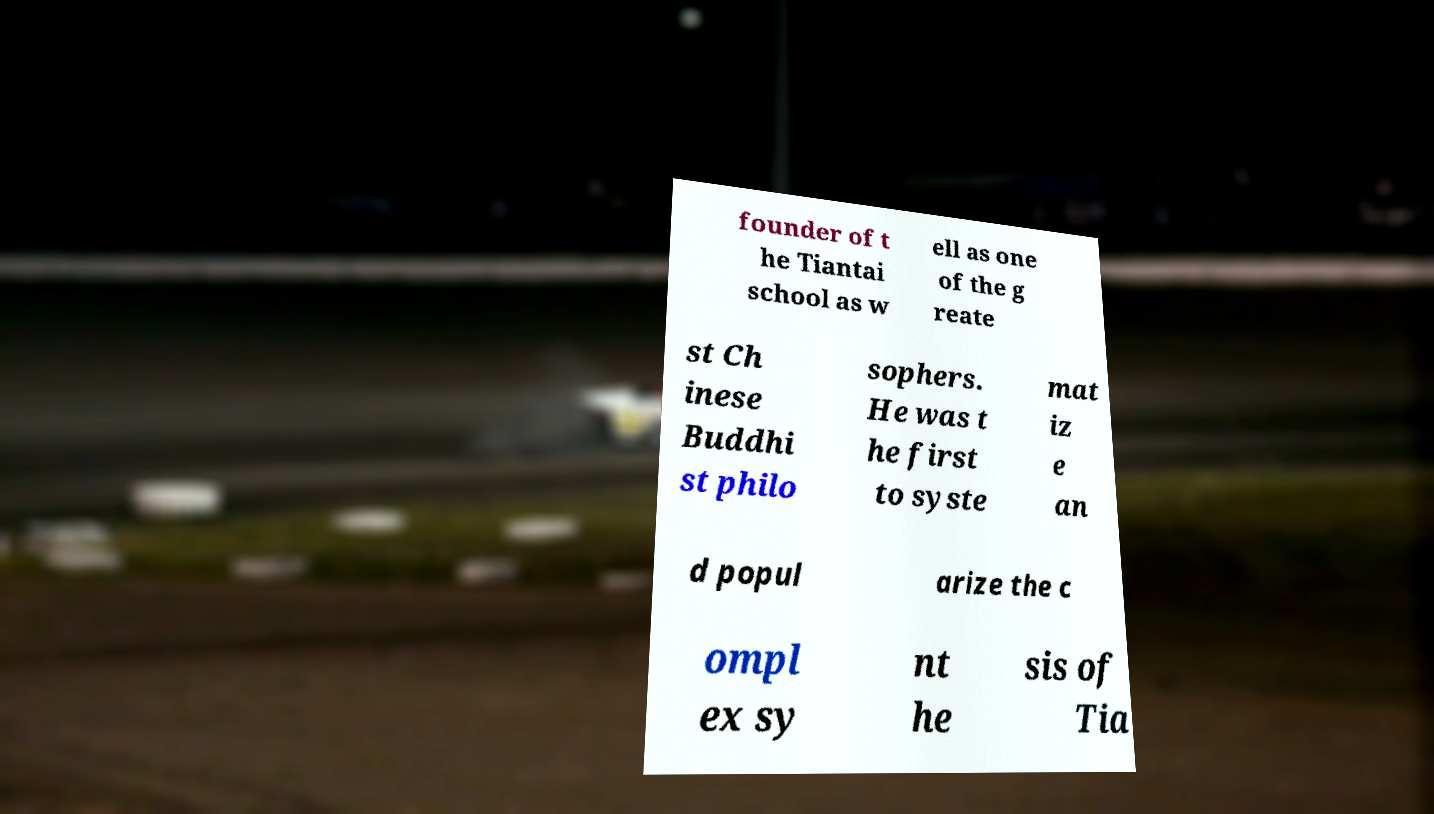Could you extract and type out the text from this image? founder of t he Tiantai school as w ell as one of the g reate st Ch inese Buddhi st philo sophers. He was t he first to syste mat iz e an d popul arize the c ompl ex sy nt he sis of Tia 